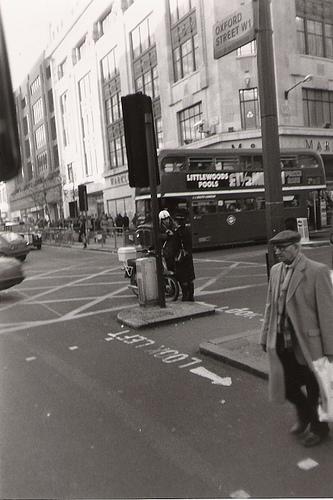Is that a real bus?
Quick response, please. Yes. Is he wearing a coat?
Answer briefly. Yes. What color is the trash can?
Give a very brief answer. Silver. What is the man near the pic doing?
Short answer required. Crossing street. Is it busy?
Answer briefly. Yes. Is this an office?
Write a very short answer. No. Is someone stepping on a crack?
Keep it brief. No. Why is the man in glasses and gray shirt walking outside with food in hand near a old building?
Give a very brief answer. Lunch time. Is this an alley?
Short answer required. No. What is on his head?
Concise answer only. Hat. What kind of bus is here?
Write a very short answer. Double decker. What country is this most likely in?
Answer briefly. England. What is the man carrying?
Quick response, please. Bag. 